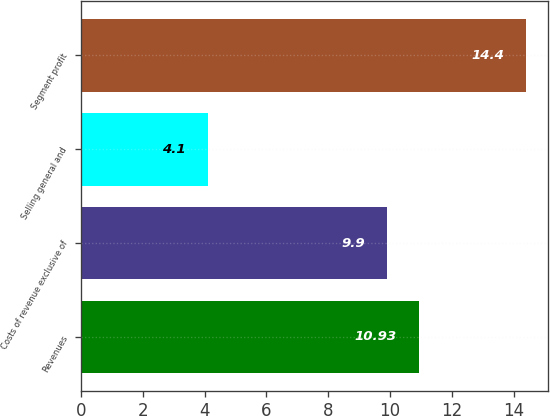Convert chart to OTSL. <chart><loc_0><loc_0><loc_500><loc_500><bar_chart><fcel>Revenues<fcel>Costs of revenue exclusive of<fcel>Selling general and<fcel>Segment profit<nl><fcel>10.93<fcel>9.9<fcel>4.1<fcel>14.4<nl></chart> 